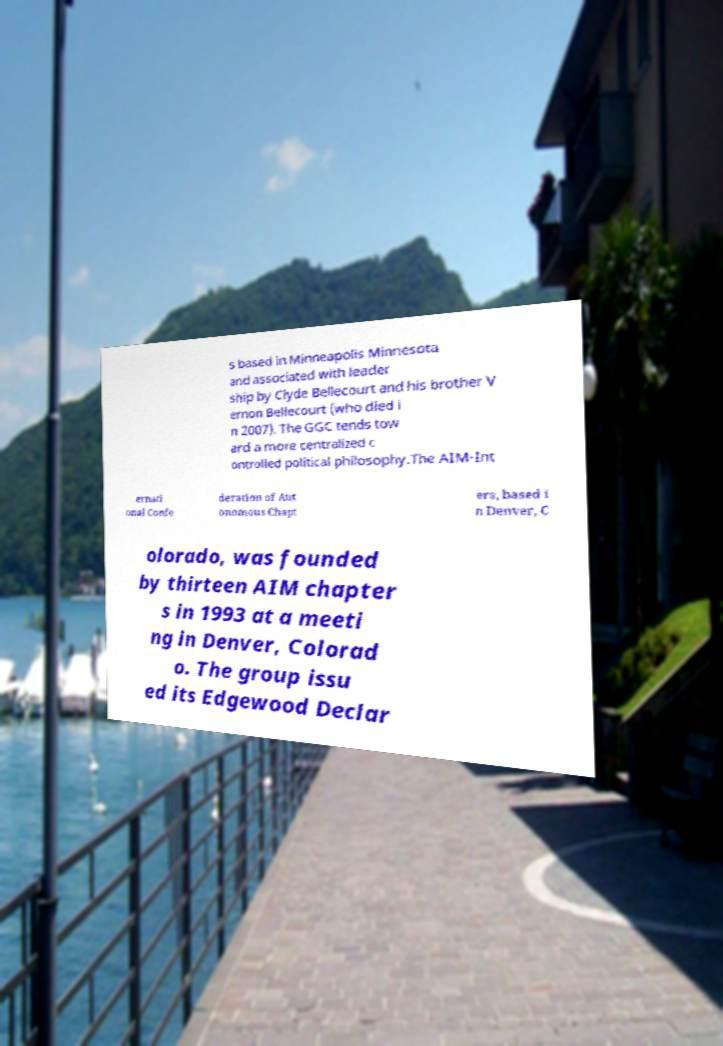Could you assist in decoding the text presented in this image and type it out clearly? s based in Minneapolis Minnesota and associated with leader ship by Clyde Bellecourt and his brother V ernon Bellecourt (who died i n 2007). The GGC tends tow ard a more centralized c ontrolled political philosophy.The AIM-Int ernati onal Confe deration of Aut onomous Chapt ers, based i n Denver, C olorado, was founded by thirteen AIM chapter s in 1993 at a meeti ng in Denver, Colorad o. The group issu ed its Edgewood Declar 